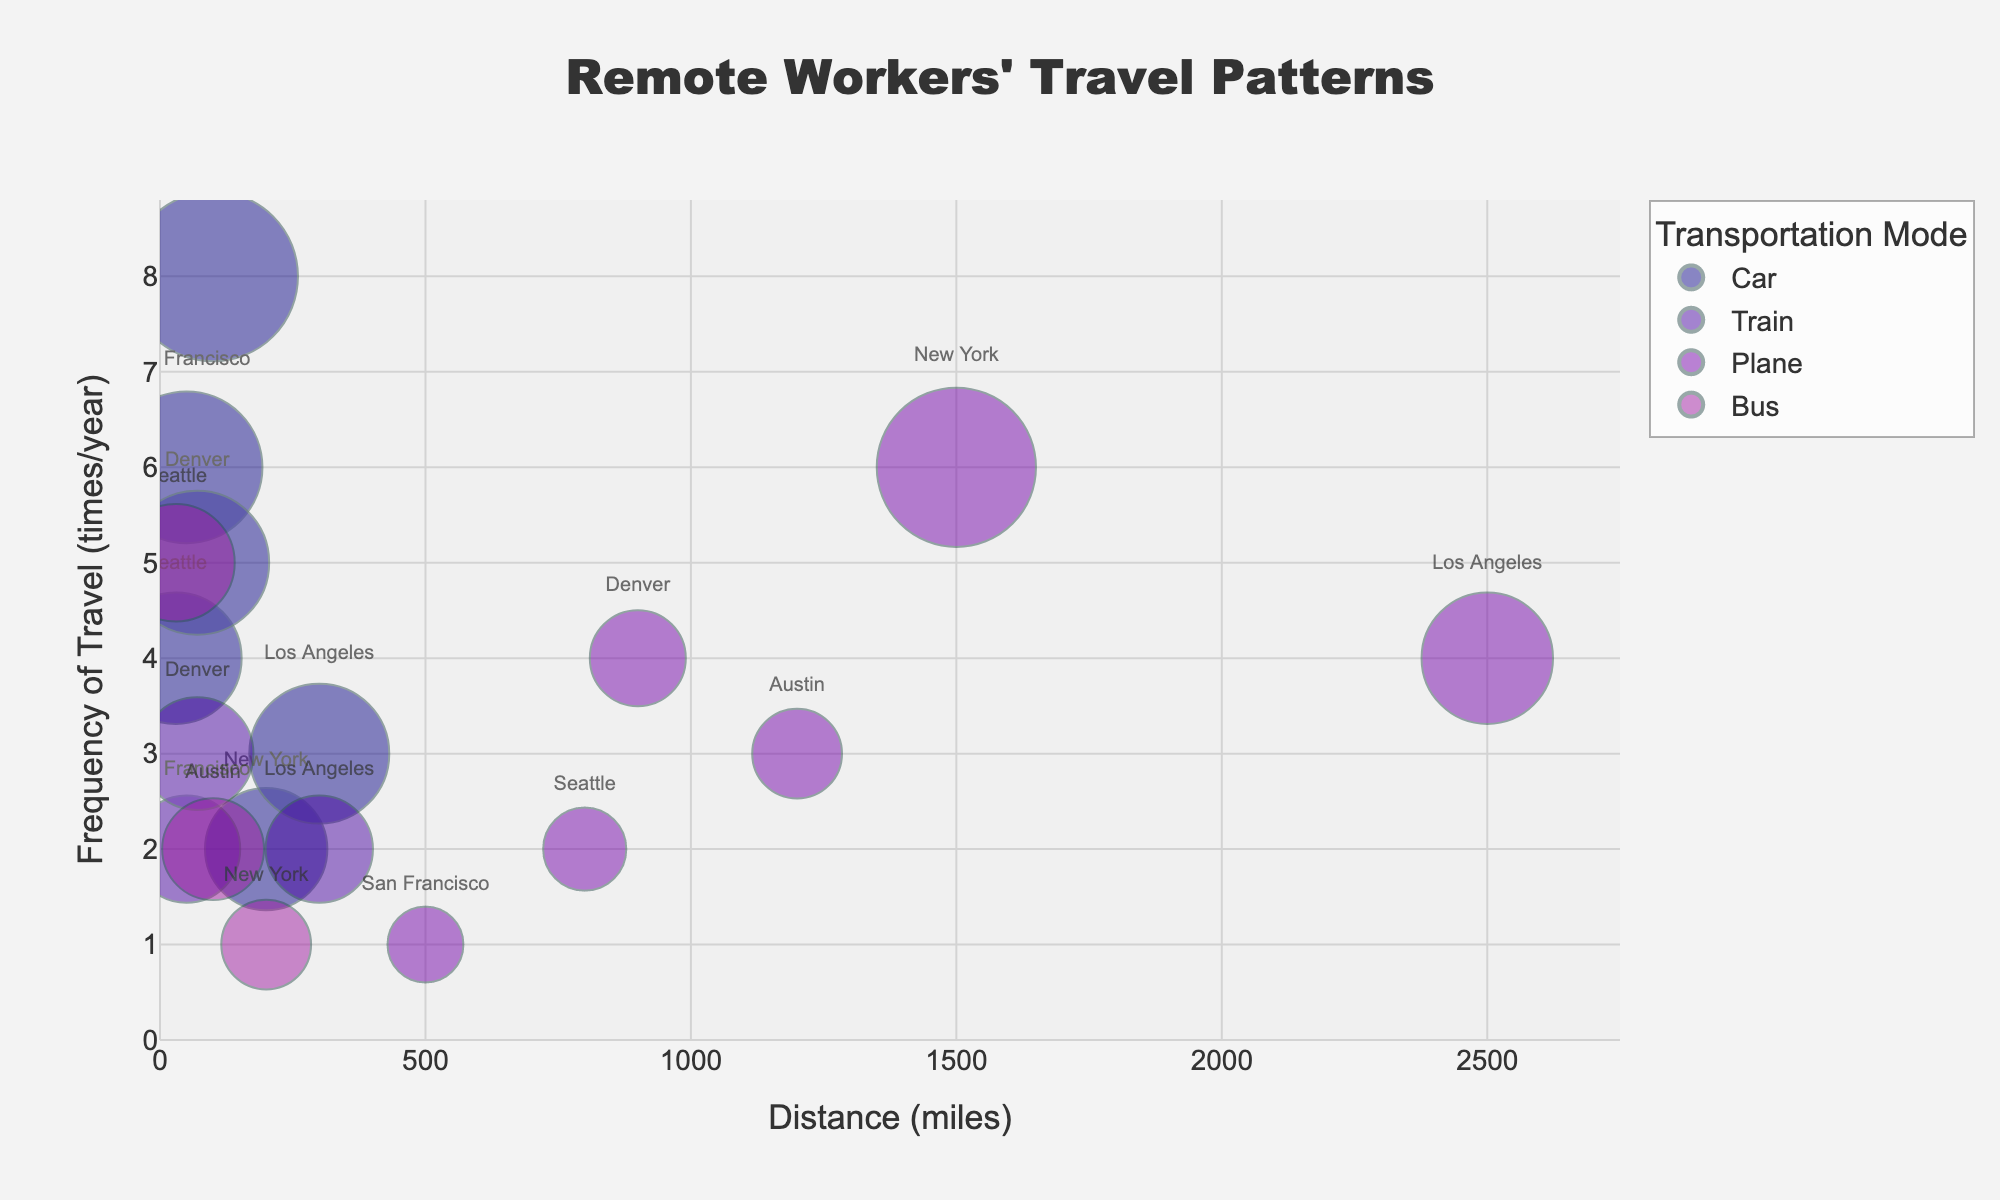What is the title of the figure? The title is typically located at the top center of the figure. Reading it directly gives us the information: "Remote Workers' Travel Patterns".
Answer: Remote Workers' Travel Patterns Which mode of transportation has the highest bubble size in New York? To find this, look at the bubbles representing New York and compare their sizes. The largest bubble size represents "Plane."
Answer: Plane How often do remote workers travel by car to Austin per year? To find this, locate the bubble representing "Car" for Austin on the y-axis, which shows the frequency of travel. The frequency is 8 times per year.
Answer: 8 times/year Which city has the longest distance traveled by remote workers using a plane? To determine this, identify the bubbles representing "Plane" and look at the x-axis for the distance. The city with the highest distance value is Los Angeles at 2500 miles.
Answer: Los Angeles What is the average distance traveled to Seattle by all modes of transportation? Calculate the average distance using the bubbles representing Seattle: (30 (Car) + 30 (Bus) + 800 (Plane)) / 3 = 860 / 3 ≈ 286.67 miles.
Answer: ≈ 286.67 miles Which city's remote workers travel most frequently using any mode of transportation? Compare the y-axis values (frequency of travel) for all cities across all modes. Austin has the highest y-axis value for "Car" at 8 times/year.
Answer: Austin Are there more frequent travels made by plane to New York or Denver? Compare the y-axis value for "Plane" for both New York and Denver. New York has a frequency of 6 times/year, and Denver has 4 times/year.
Answer: New York How many different modes of transportation are represented in the figure? By looking at the legend, we see the modes of transportation: "Car," "Train," "Plane," and "Bus." There are 4 different modes.
Answer: 4 Which mode of transportation has the highest distance in the entire dataset? Identify the maximum value on the x-axis. "Plane" to Los Angeles has the highest distance at 2500 miles.
Answer: Plane Which city has the smallest bubble for plane transportation, and what is its size? Locate the smallest bubble for plane transportation by comparing bubble sizes. The smallest size is for San Francisco at 50.
Answer: San Francisco, 50 